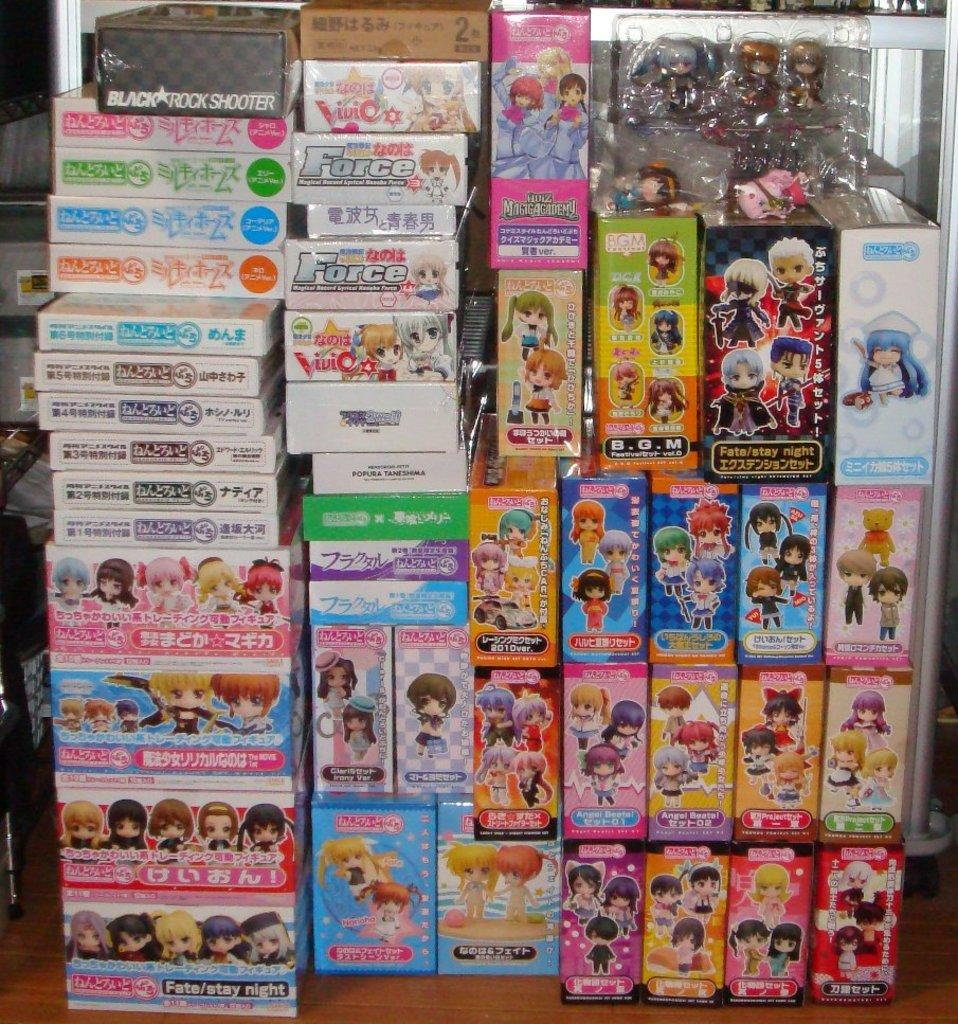What type of objects are visible in the image? There are toy stock boxes in the image. Can you describe the purpose of these objects? The toy stock boxes are likely used for storing or organizing toys. Are there any other items visible in the image? The provided facts do not mention any other items in the image. How many toes can be seen on the government in the image? There is no government present in the image, and therefore no toes can be observed. 